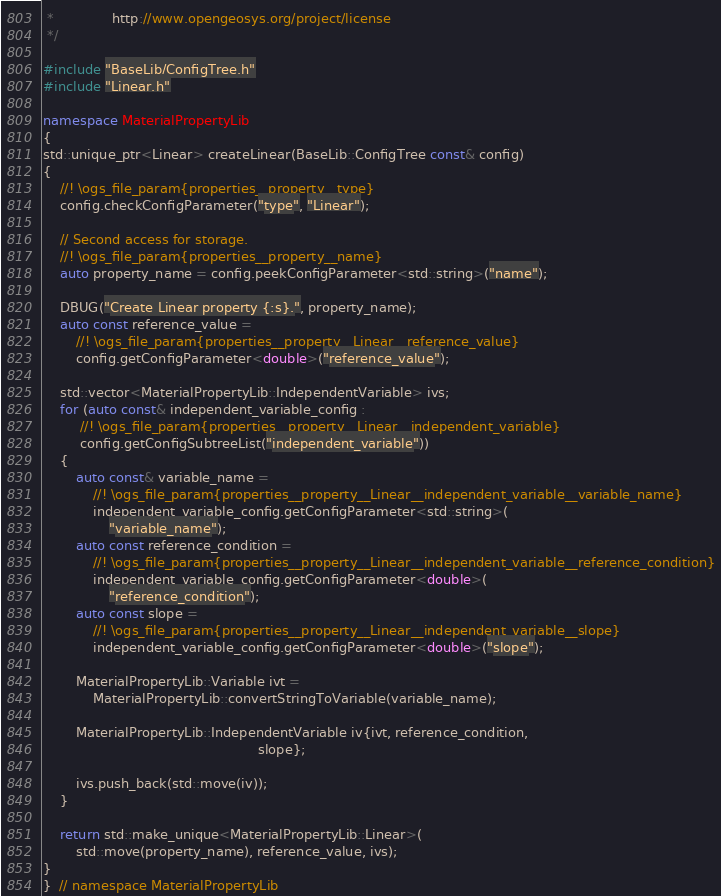Convert code to text. <code><loc_0><loc_0><loc_500><loc_500><_C++_> *              http://www.opengeosys.org/project/license
 */

#include "BaseLib/ConfigTree.h"
#include "Linear.h"

namespace MaterialPropertyLib
{
std::unique_ptr<Linear> createLinear(BaseLib::ConfigTree const& config)
{
    //! \ogs_file_param{properties__property__type}
    config.checkConfigParameter("type", "Linear");

    // Second access for storage.
    //! \ogs_file_param{properties__property__name}
    auto property_name = config.peekConfigParameter<std::string>("name");

    DBUG("Create Linear property {:s}.", property_name);
    auto const reference_value =
        //! \ogs_file_param{properties__property__Linear__reference_value}
        config.getConfigParameter<double>("reference_value");

    std::vector<MaterialPropertyLib::IndependentVariable> ivs;
    for (auto const& independent_variable_config :
         //! \ogs_file_param{properties__property__Linear__independent_variable}
         config.getConfigSubtreeList("independent_variable"))
    {
        auto const& variable_name =
            //! \ogs_file_param{properties__property__Linear__independent_variable__variable_name}
            independent_variable_config.getConfigParameter<std::string>(
                "variable_name");
        auto const reference_condition =
            //! \ogs_file_param{properties__property__Linear__independent_variable__reference_condition}
            independent_variable_config.getConfigParameter<double>(
                "reference_condition");
        auto const slope =
            //! \ogs_file_param{properties__property__Linear__independent_variable__slope}
            independent_variable_config.getConfigParameter<double>("slope");

        MaterialPropertyLib::Variable ivt =
            MaterialPropertyLib::convertStringToVariable(variable_name);

        MaterialPropertyLib::IndependentVariable iv{ivt, reference_condition,
                                                    slope};

        ivs.push_back(std::move(iv));
    }

    return std::make_unique<MaterialPropertyLib::Linear>(
        std::move(property_name), reference_value, ivs);
}
}  // namespace MaterialPropertyLib
</code> 